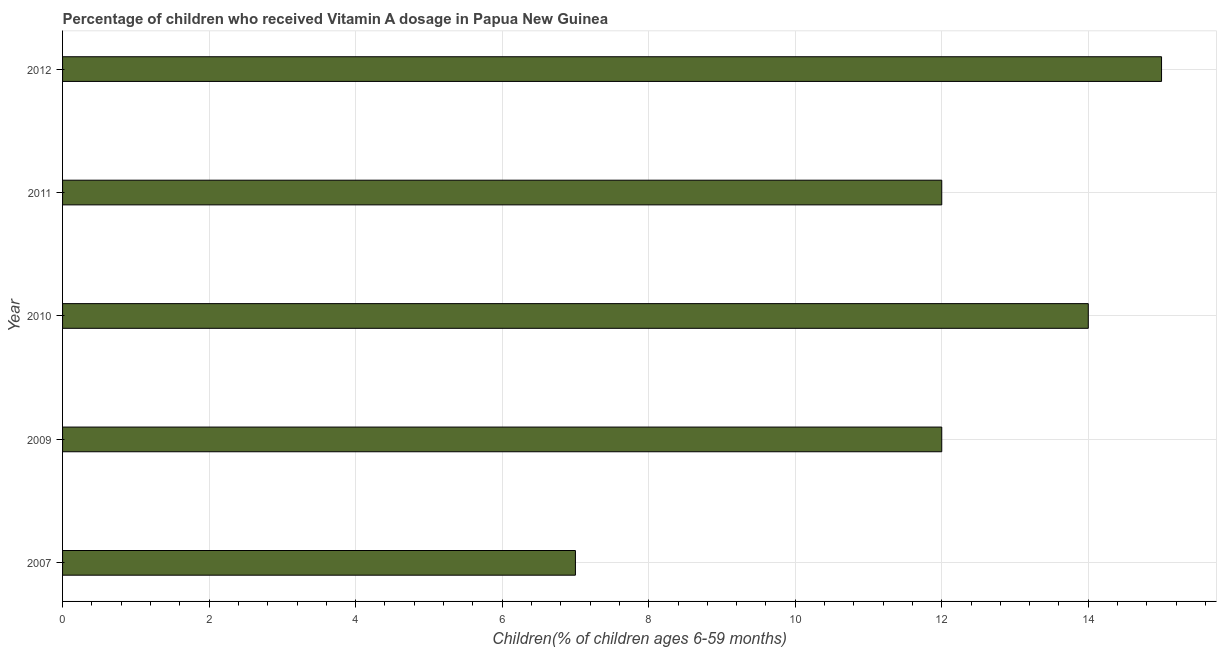Does the graph contain any zero values?
Keep it short and to the point. No. What is the title of the graph?
Give a very brief answer. Percentage of children who received Vitamin A dosage in Papua New Guinea. What is the label or title of the X-axis?
Keep it short and to the point. Children(% of children ages 6-59 months). What is the label or title of the Y-axis?
Provide a succinct answer. Year. What is the vitamin a supplementation coverage rate in 2010?
Give a very brief answer. 14. Across all years, what is the maximum vitamin a supplementation coverage rate?
Keep it short and to the point. 15. What is the sum of the vitamin a supplementation coverage rate?
Your answer should be compact. 60. What is the difference between the vitamin a supplementation coverage rate in 2011 and 2012?
Give a very brief answer. -3. What is the median vitamin a supplementation coverage rate?
Your answer should be compact. 12. What is the ratio of the vitamin a supplementation coverage rate in 2010 to that in 2011?
Ensure brevity in your answer.  1.17. What is the difference between the highest and the second highest vitamin a supplementation coverage rate?
Keep it short and to the point. 1. Is the sum of the vitamin a supplementation coverage rate in 2010 and 2011 greater than the maximum vitamin a supplementation coverage rate across all years?
Keep it short and to the point. Yes. What is the difference between the highest and the lowest vitamin a supplementation coverage rate?
Your response must be concise. 8. How many bars are there?
Offer a very short reply. 5. How many years are there in the graph?
Your answer should be very brief. 5. What is the difference between two consecutive major ticks on the X-axis?
Ensure brevity in your answer.  2. Are the values on the major ticks of X-axis written in scientific E-notation?
Ensure brevity in your answer.  No. What is the Children(% of children ages 6-59 months) in 2007?
Your answer should be very brief. 7. What is the Children(% of children ages 6-59 months) in 2010?
Make the answer very short. 14. What is the difference between the Children(% of children ages 6-59 months) in 2007 and 2009?
Keep it short and to the point. -5. What is the difference between the Children(% of children ages 6-59 months) in 2009 and 2010?
Offer a very short reply. -2. What is the difference between the Children(% of children ages 6-59 months) in 2009 and 2011?
Keep it short and to the point. 0. What is the difference between the Children(% of children ages 6-59 months) in 2009 and 2012?
Ensure brevity in your answer.  -3. What is the difference between the Children(% of children ages 6-59 months) in 2010 and 2011?
Your answer should be compact. 2. What is the difference between the Children(% of children ages 6-59 months) in 2010 and 2012?
Provide a short and direct response. -1. What is the ratio of the Children(% of children ages 6-59 months) in 2007 to that in 2009?
Offer a terse response. 0.58. What is the ratio of the Children(% of children ages 6-59 months) in 2007 to that in 2011?
Provide a short and direct response. 0.58. What is the ratio of the Children(% of children ages 6-59 months) in 2007 to that in 2012?
Your answer should be very brief. 0.47. What is the ratio of the Children(% of children ages 6-59 months) in 2009 to that in 2010?
Your answer should be compact. 0.86. What is the ratio of the Children(% of children ages 6-59 months) in 2009 to that in 2011?
Give a very brief answer. 1. What is the ratio of the Children(% of children ages 6-59 months) in 2010 to that in 2011?
Ensure brevity in your answer.  1.17. What is the ratio of the Children(% of children ages 6-59 months) in 2010 to that in 2012?
Offer a terse response. 0.93. 